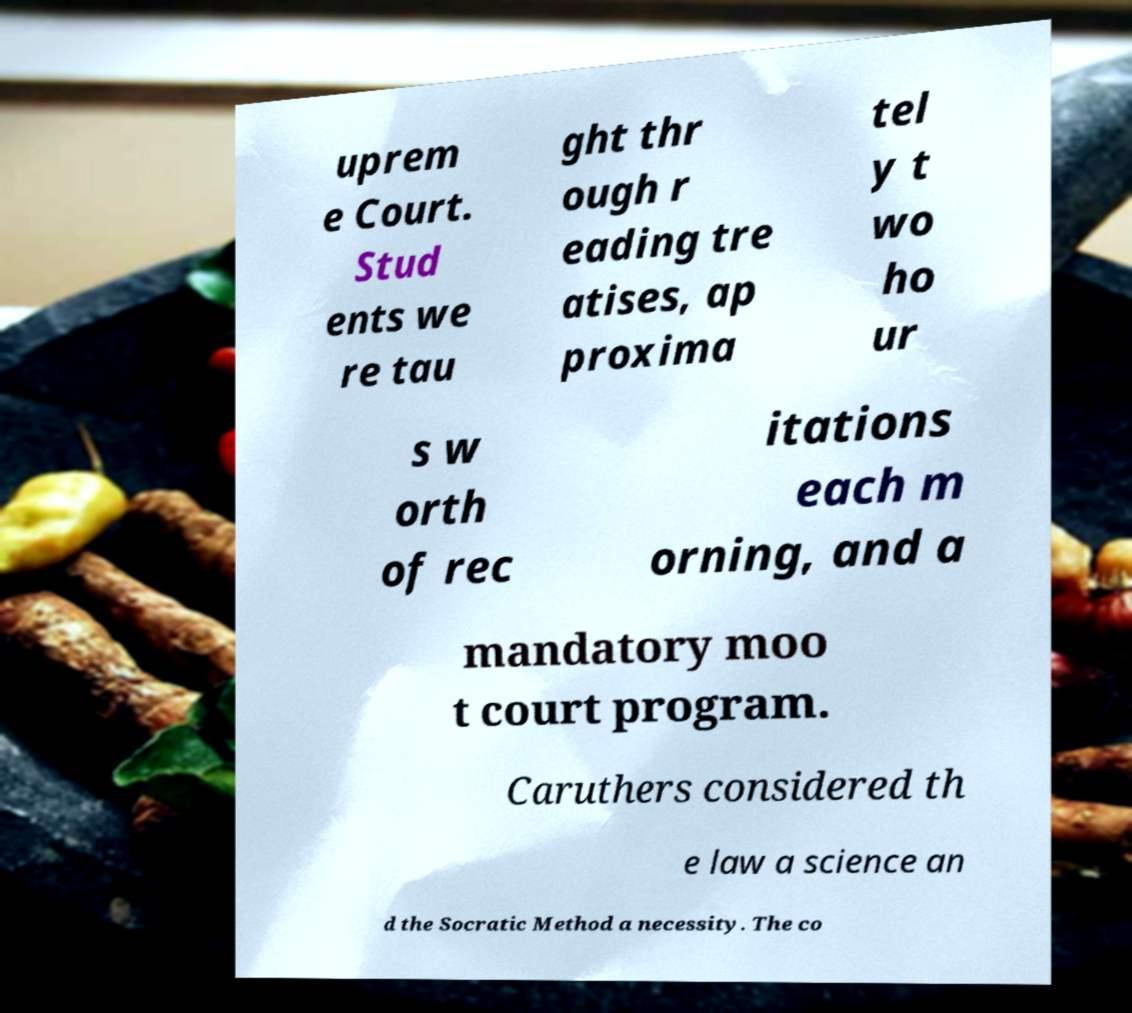Can you read and provide the text displayed in the image?This photo seems to have some interesting text. Can you extract and type it out for me? uprem e Court. Stud ents we re tau ght thr ough r eading tre atises, ap proxima tel y t wo ho ur s w orth of rec itations each m orning, and a mandatory moo t court program. Caruthers considered th e law a science an d the Socratic Method a necessity. The co 